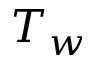Convert formula to latex. <formula><loc_0><loc_0><loc_500><loc_500>T _ { w }</formula> 